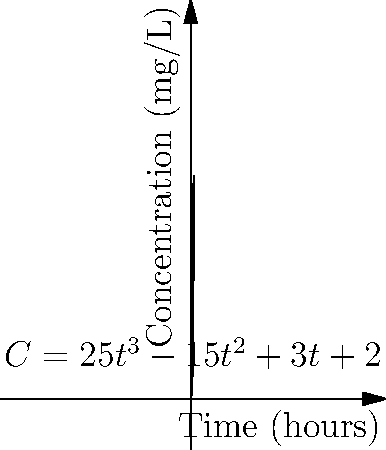A drug's plasma concentration (C) over time (t) is given by the function $C = 25t^3 - 15t^2 + 3t + 2$, where C is in mg/L and t is in hours. Calculate the area under the curve (AUC) from t = 0 to t = 2 hours using polynomial integration. To calculate the AUC, we need to integrate the concentration function from t = 0 to t = 2:

1) Set up the definite integral:
   $AUC = \int_0^2 (25t^3 - 15t^2 + 3t + 2) dt$

2) Integrate each term:
   $\int 25t^3 dt = \frac{25t^4}{4}$
   $\int -15t^2 dt = -5t^3$
   $\int 3t dt = \frac{3t^2}{2}$
   $\int 2 dt = 2t$

3) Apply the fundamental theorem of calculus:
   $AUC = [\frac{25t^4}{4} - 5t^3 + \frac{3t^2}{2} + 2t]_0^2$

4) Evaluate at t = 2 and t = 0:
   At t = 2: $\frac{25(2^4)}{4} - 5(2^3) + \frac{3(2^2)}{2} + 2(2) = 100 - 40 + 6 + 4 = 70$
   At t = 0: $\frac{25(0^4)}{4} - 5(0^3) + \frac{3(0^2)}{2} + 2(0) = 0$

5) Subtract:
   $AUC = 70 - 0 = 70$

Therefore, the AUC from t = 0 to t = 2 hours is 70 mg·h/L.
Answer: 70 mg·h/L 